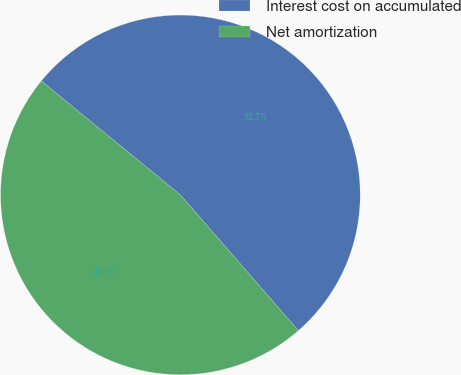<chart> <loc_0><loc_0><loc_500><loc_500><pie_chart><fcel>Interest cost on accumulated<fcel>Net amortization<nl><fcel>52.69%<fcel>47.31%<nl></chart> 